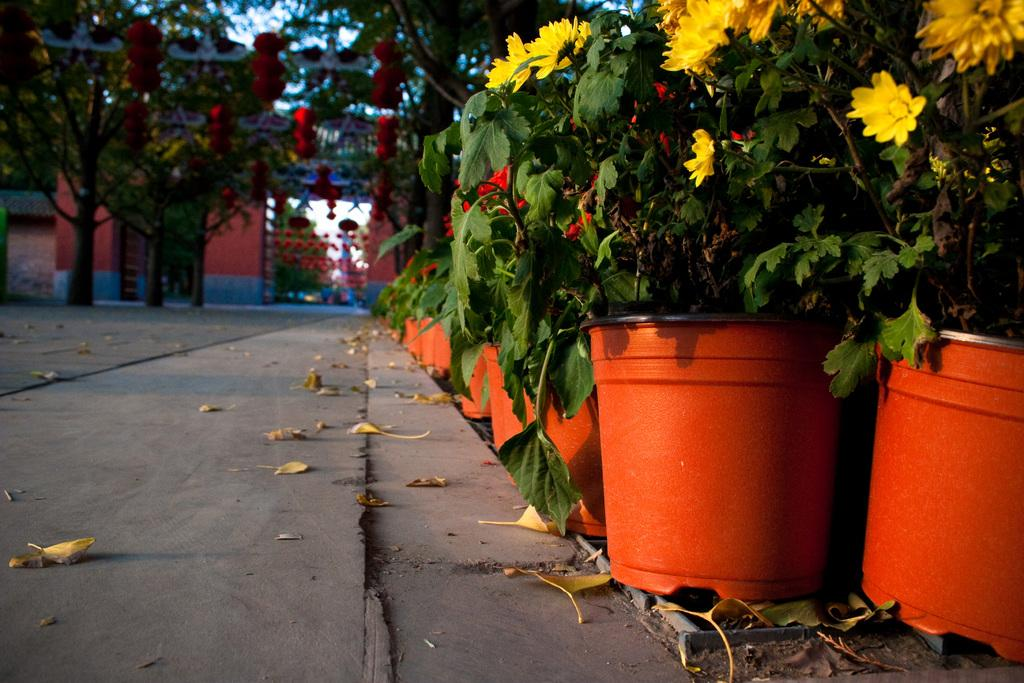What type of vegetation can be seen in the image? There are trees and plants with flowers in the image. Can you describe the background of the image? There is a building in the background of the image. What type of coil is wrapped around the tree in the image? There is no coil present in the image; it only features trees and plants with flowers. 